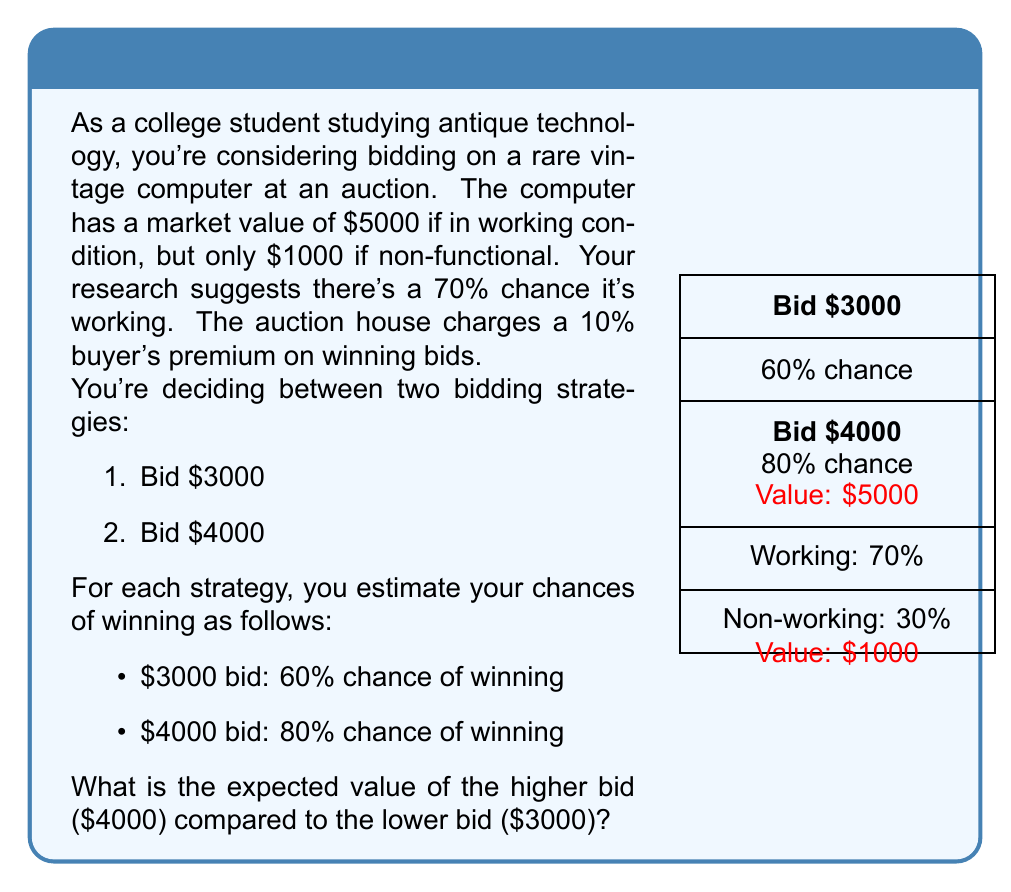Show me your answer to this math problem. Let's calculate the expected value for each bidding strategy:

1. For the $3000 bid:
   - Probability of winning: 60% = 0.6
   - Expected value if won:
     $$(0.7 \times 5000) + (0.3 \times 1000) = 3500 + 300 = 3800$$
   - Cost if won (including buyer's premium):
     $$3000 \times 1.1 = 3300$$
   - Net value if won: $3800 - 3300 = 500$
   - Expected value: $0.6 \times 500 = 300$

2. For the $4000 bid:
   - Probability of winning: 80% = 0.8
   - Expected value if won: $3800$ (same as above)
   - Cost if won (including buyer's premium):
     $$4000 \times 1.1 = 4400$$
   - Net value if won: $3800 - 4400 = -600$
   - Expected value: $0.8 \times (-600) = -480$

The difference in expected value:
$$-480 - 300 = -780$$

This means the higher bid ($4000) has an expected value $780 lower than the lower bid ($3000).
Answer: $-780 